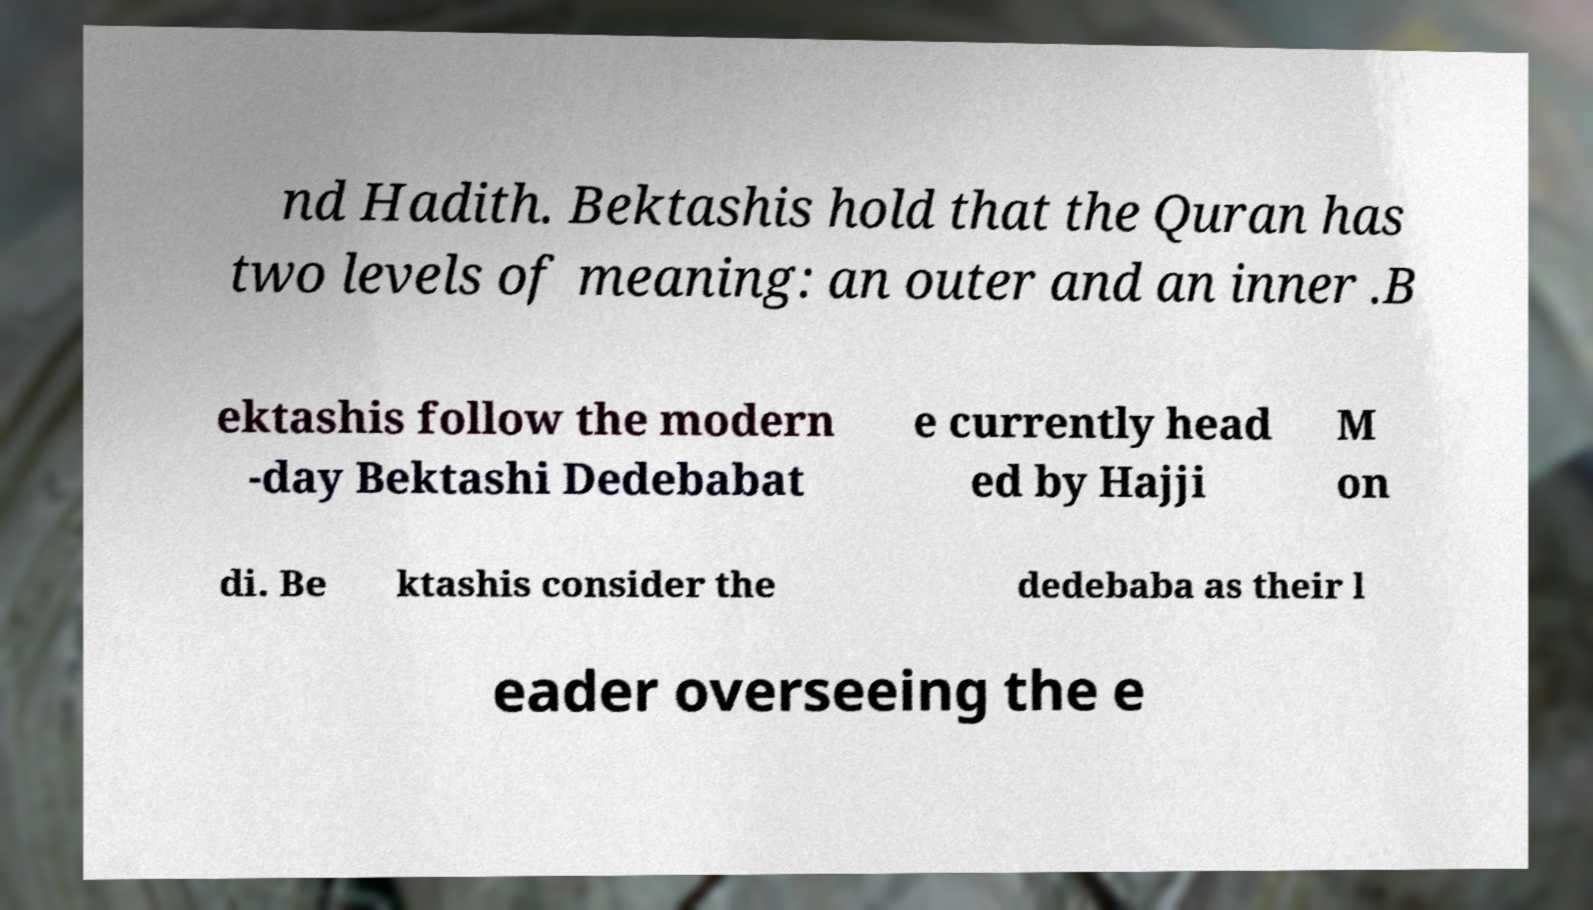Can you read and provide the text displayed in the image?This photo seems to have some interesting text. Can you extract and type it out for me? nd Hadith. Bektashis hold that the Quran has two levels of meaning: an outer and an inner .B ektashis follow the modern -day Bektashi Dedebabat e currently head ed by Hajji M on di. Be ktashis consider the dedebaba as their l eader overseeing the e 